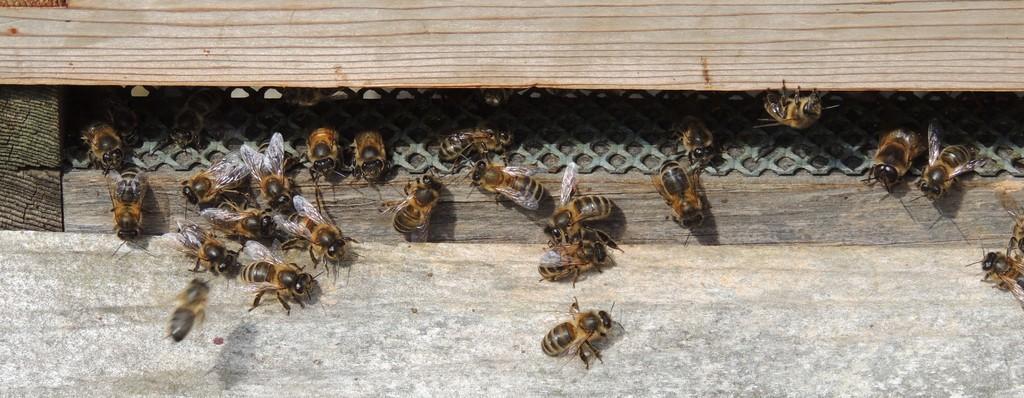Can you describe this image briefly? In this image, we can see some black and brown color bees. 